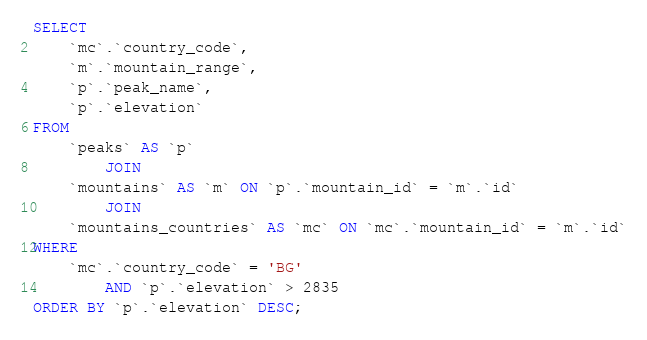Convert code to text. <code><loc_0><loc_0><loc_500><loc_500><_SQL_>SELECT 
    `mc`.`country_code`,
    `m`.`mountain_range`,
    `p`.`peak_name`,
    `p`.`elevation`
FROM
    `peaks` AS `p`
        JOIN
    `mountains` AS `m` ON `p`.`mountain_id` = `m`.`id`
        JOIN
    `mountains_countries` AS `mc` ON `mc`.`mountain_id` = `m`.`id`
WHERE
    `mc`.`country_code` = 'BG'
        AND `p`.`elevation` > 2835
ORDER BY `p`.`elevation` DESC;

</code> 